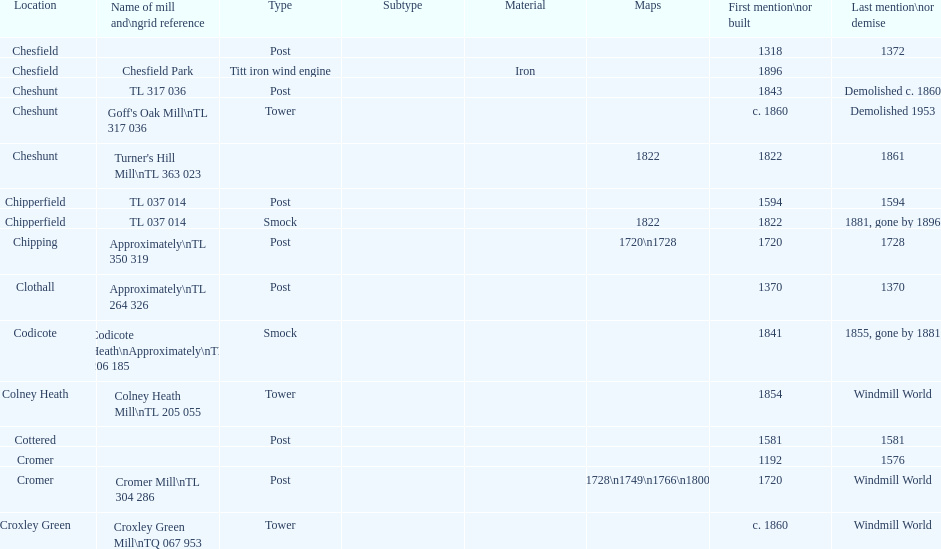How many locations have or had at least 2 windmills? 4. 